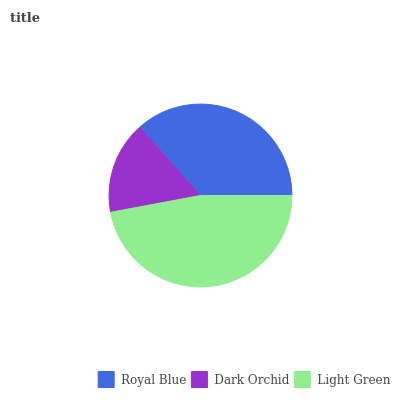Is Dark Orchid the minimum?
Answer yes or no. Yes. Is Light Green the maximum?
Answer yes or no. Yes. Is Light Green the minimum?
Answer yes or no. No. Is Dark Orchid the maximum?
Answer yes or no. No. Is Light Green greater than Dark Orchid?
Answer yes or no. Yes. Is Dark Orchid less than Light Green?
Answer yes or no. Yes. Is Dark Orchid greater than Light Green?
Answer yes or no. No. Is Light Green less than Dark Orchid?
Answer yes or no. No. Is Royal Blue the high median?
Answer yes or no. Yes. Is Royal Blue the low median?
Answer yes or no. Yes. Is Light Green the high median?
Answer yes or no. No. Is Light Green the low median?
Answer yes or no. No. 